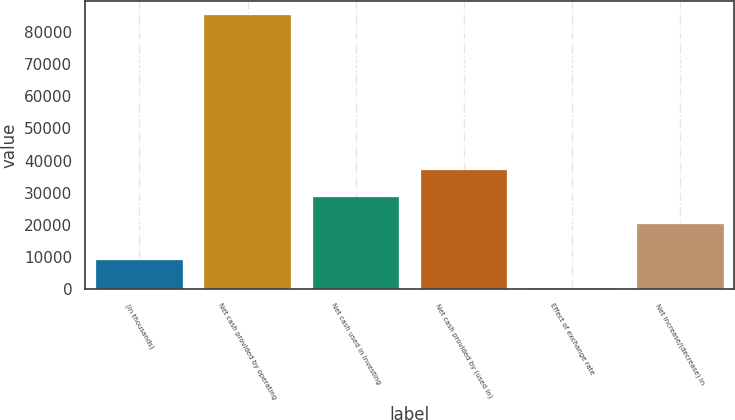Convert chart. <chart><loc_0><loc_0><loc_500><loc_500><bar_chart><fcel>(in thousands)<fcel>Net cash provided by operating<fcel>Net cash used in investing<fcel>Net cash provided by (used in)<fcel>Effect of exchange rate<fcel>Net increase/(decrease) in<nl><fcel>9016.9<fcel>85201<fcel>28743.9<fcel>37208.8<fcel>552<fcel>20279<nl></chart> 